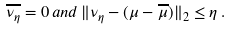Convert formula to latex. <formula><loc_0><loc_0><loc_500><loc_500>\overline { \nu _ { \eta } } = 0 \, a n d \, \| \nu _ { \eta } - ( \mu - \overline { \mu } ) \| _ { 2 } \leq \eta \, .</formula> 